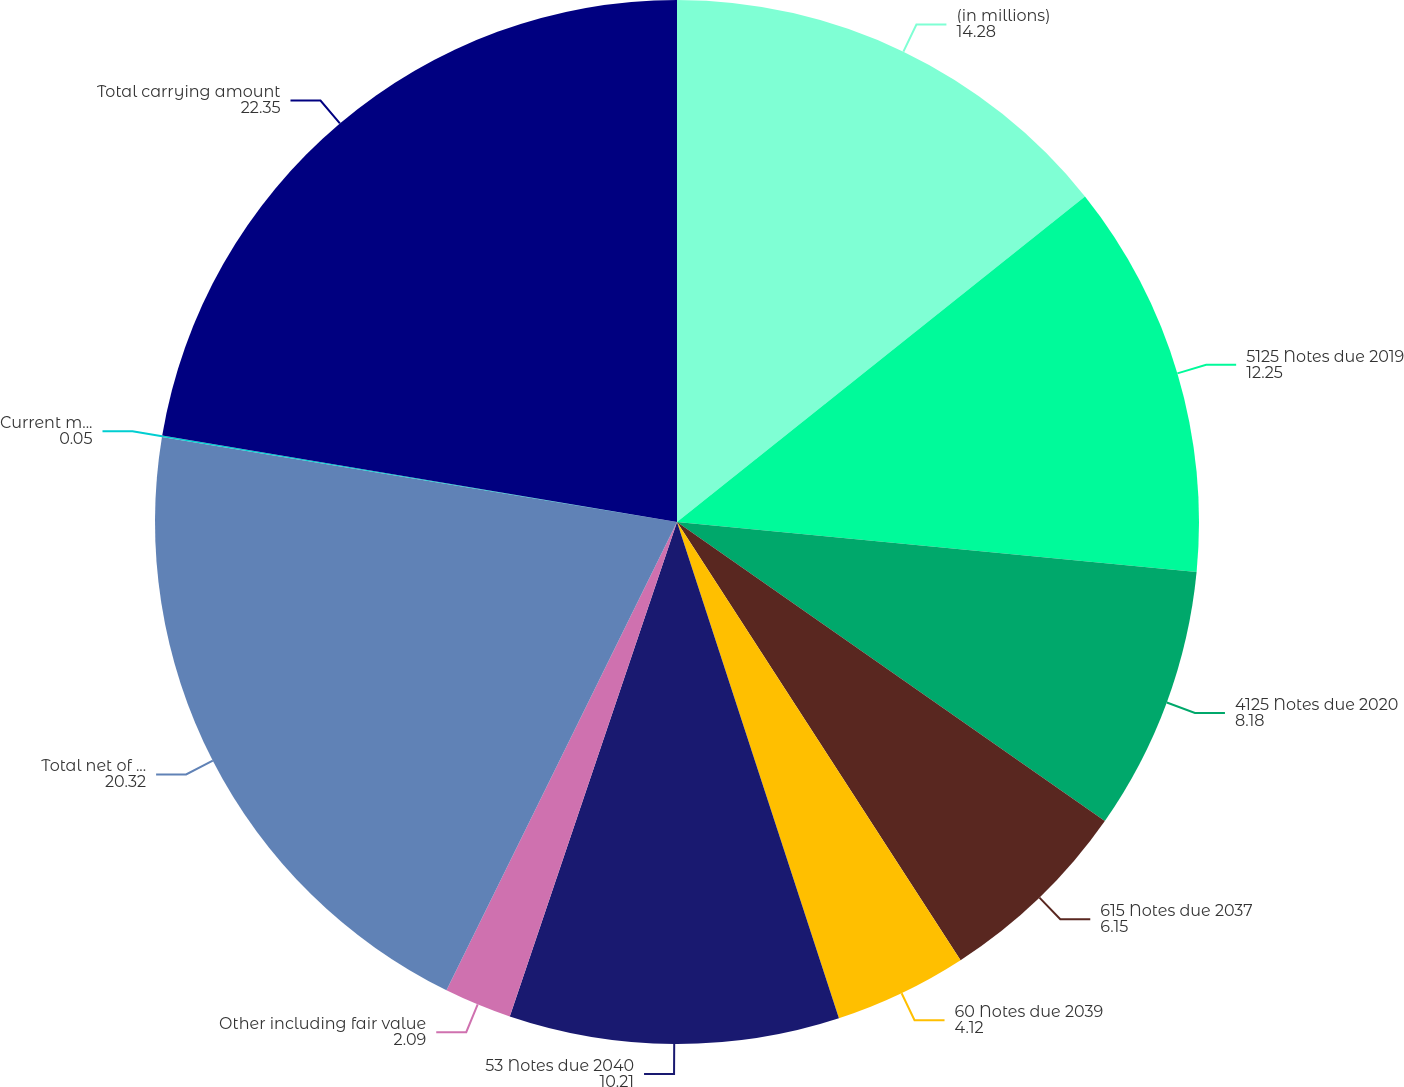Convert chart to OTSL. <chart><loc_0><loc_0><loc_500><loc_500><pie_chart><fcel>(in millions)<fcel>5125 Notes due 2019<fcel>4125 Notes due 2020<fcel>615 Notes due 2037<fcel>60 Notes due 2039<fcel>53 Notes due 2040<fcel>Other including fair value<fcel>Total net of current<fcel>Current maturities of<fcel>Total carrying amount<nl><fcel>14.28%<fcel>12.25%<fcel>8.18%<fcel>6.15%<fcel>4.12%<fcel>10.21%<fcel>2.09%<fcel>20.32%<fcel>0.05%<fcel>22.35%<nl></chart> 